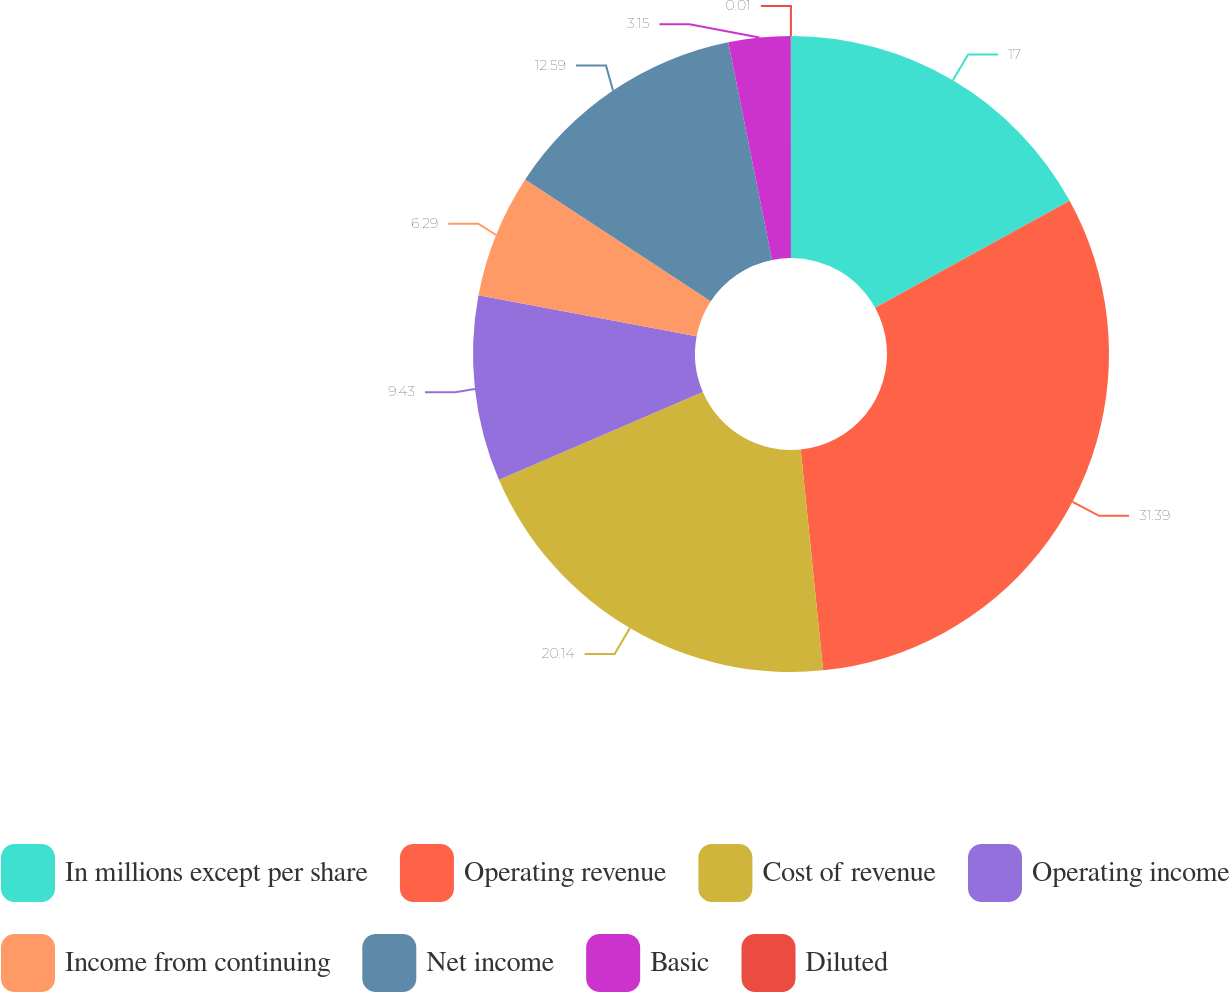<chart> <loc_0><loc_0><loc_500><loc_500><pie_chart><fcel>In millions except per share<fcel>Operating revenue<fcel>Cost of revenue<fcel>Operating income<fcel>Income from continuing<fcel>Net income<fcel>Basic<fcel>Diluted<nl><fcel>17.0%<fcel>31.39%<fcel>20.14%<fcel>9.43%<fcel>6.29%<fcel>12.59%<fcel>3.15%<fcel>0.01%<nl></chart> 